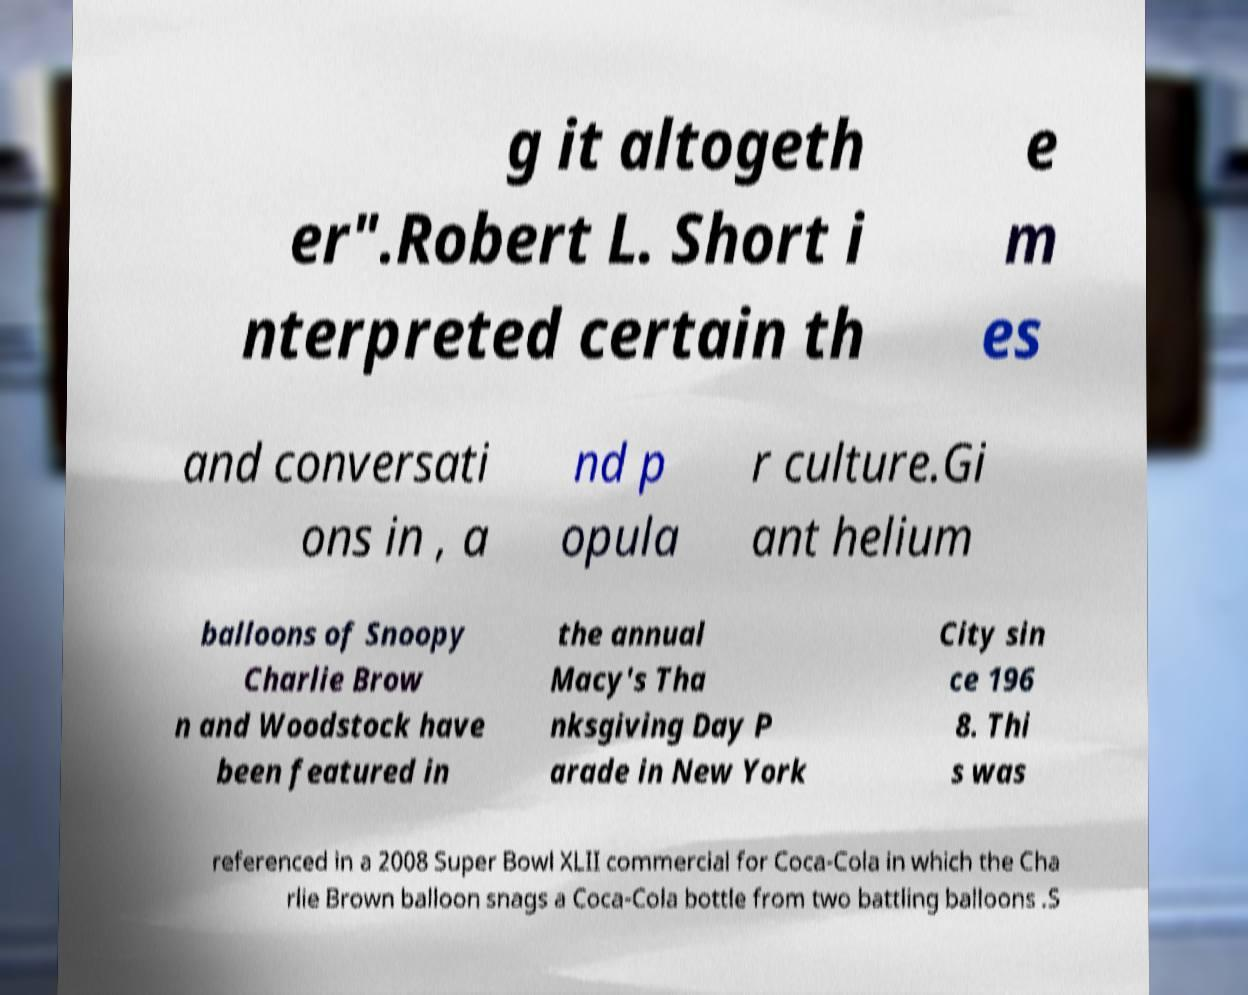I need the written content from this picture converted into text. Can you do that? g it altogeth er".Robert L. Short i nterpreted certain th e m es and conversati ons in , a nd p opula r culture.Gi ant helium balloons of Snoopy Charlie Brow n and Woodstock have been featured in the annual Macy's Tha nksgiving Day P arade in New York City sin ce 196 8. Thi s was referenced in a 2008 Super Bowl XLII commercial for Coca-Cola in which the Cha rlie Brown balloon snags a Coca-Cola bottle from two battling balloons .S 